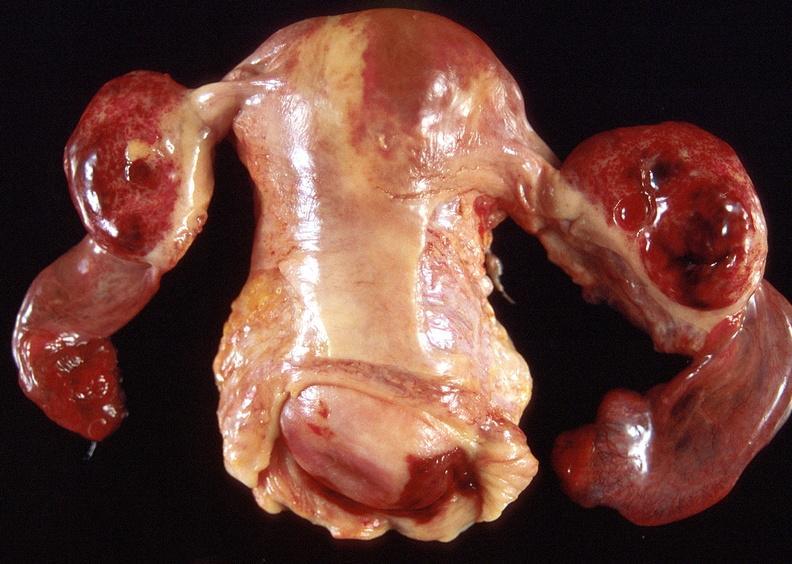what does this image show?
Answer the question using a single word or phrase. Ovarian cysts 